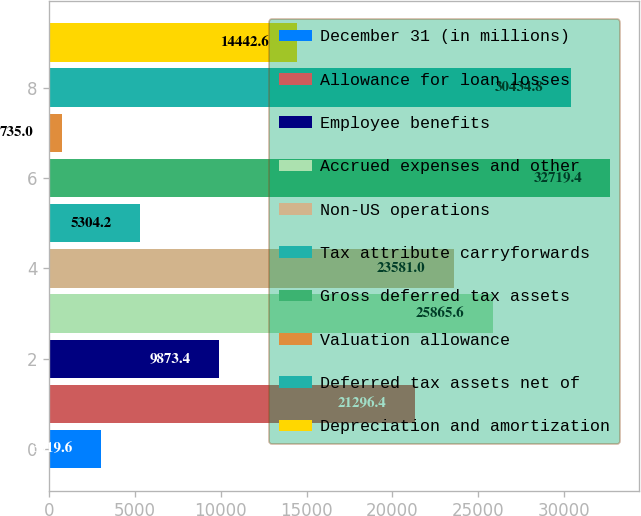Convert chart to OTSL. <chart><loc_0><loc_0><loc_500><loc_500><bar_chart><fcel>December 31 (in millions)<fcel>Allowance for loan losses<fcel>Employee benefits<fcel>Accrued expenses and other<fcel>Non-US operations<fcel>Tax attribute carryforwards<fcel>Gross deferred tax assets<fcel>Valuation allowance<fcel>Deferred tax assets net of<fcel>Depreciation and amortization<nl><fcel>3019.6<fcel>21296.4<fcel>9873.4<fcel>25865.6<fcel>23581<fcel>5304.2<fcel>32719.4<fcel>735<fcel>30434.8<fcel>14442.6<nl></chart> 